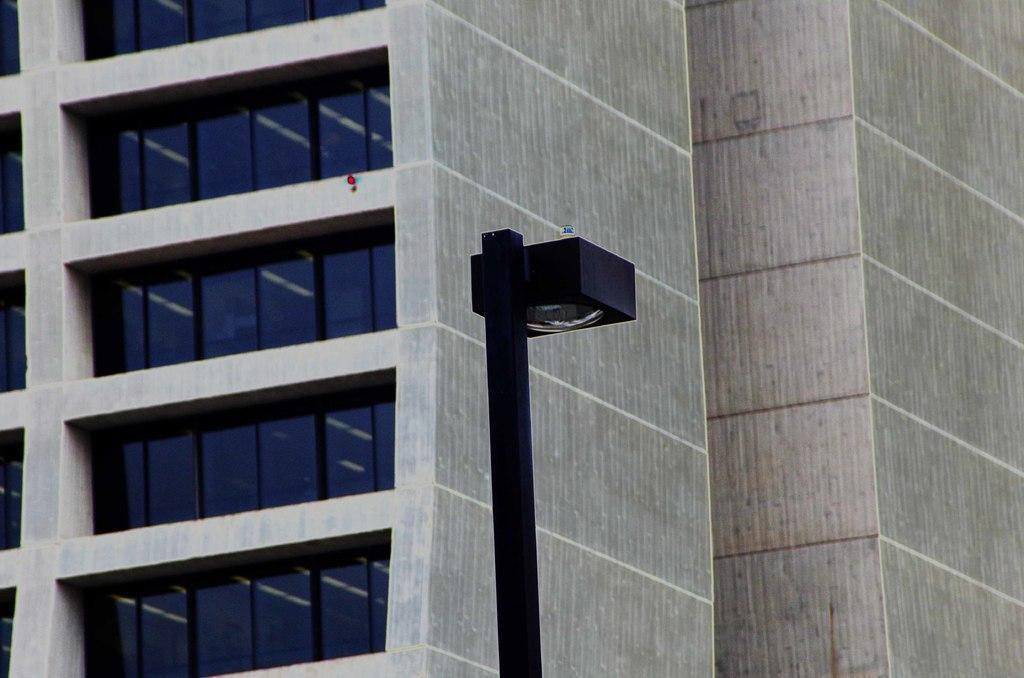Could you give a brief overview of what you see in this image? This image consists of a building along with the windows. And we can see a pole along with a lamp. 